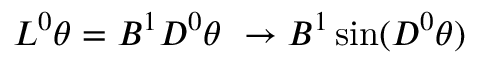<formula> <loc_0><loc_0><loc_500><loc_500>L ^ { 0 } \theta = B ^ { 1 } D ^ { 0 } \theta \ \rightarrow B ^ { 1 } \sin ( D ^ { 0 } \theta )</formula> 